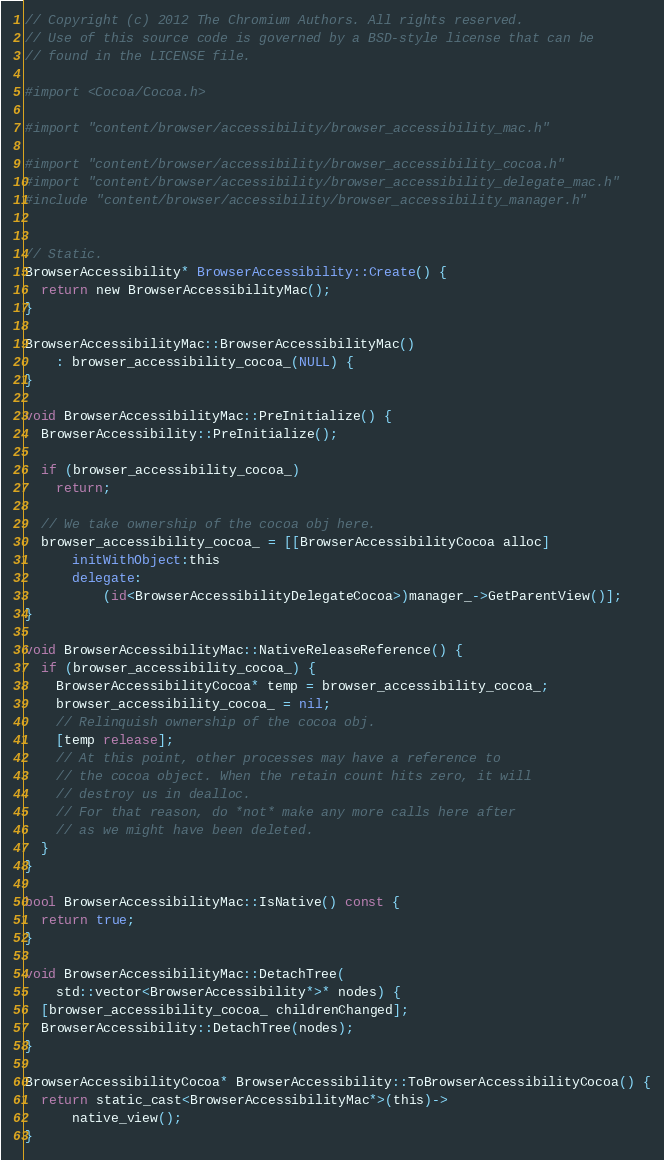<code> <loc_0><loc_0><loc_500><loc_500><_ObjectiveC_>// Copyright (c) 2012 The Chromium Authors. All rights reserved.
// Use of this source code is governed by a BSD-style license that can be
// found in the LICENSE file.

#import <Cocoa/Cocoa.h>

#import "content/browser/accessibility/browser_accessibility_mac.h"

#import "content/browser/accessibility/browser_accessibility_cocoa.h"
#import "content/browser/accessibility/browser_accessibility_delegate_mac.h"
#include "content/browser/accessibility/browser_accessibility_manager.h"


// Static.
BrowserAccessibility* BrowserAccessibility::Create() {
  return new BrowserAccessibilityMac();
}

BrowserAccessibilityMac::BrowserAccessibilityMac()
    : browser_accessibility_cocoa_(NULL) {
}

void BrowserAccessibilityMac::PreInitialize() {
  BrowserAccessibility::PreInitialize();

  if (browser_accessibility_cocoa_)
    return;

  // We take ownership of the cocoa obj here.
  browser_accessibility_cocoa_ = [[BrowserAccessibilityCocoa alloc]
      initWithObject:this
      delegate:
          (id<BrowserAccessibilityDelegateCocoa>)manager_->GetParentView()];
}

void BrowserAccessibilityMac::NativeReleaseReference() {
  if (browser_accessibility_cocoa_) {
    BrowserAccessibilityCocoa* temp = browser_accessibility_cocoa_;
    browser_accessibility_cocoa_ = nil;
    // Relinquish ownership of the cocoa obj.
    [temp release];
    // At this point, other processes may have a reference to
    // the cocoa object. When the retain count hits zero, it will
    // destroy us in dealloc.
    // For that reason, do *not* make any more calls here after
    // as we might have been deleted.
  }
}

bool BrowserAccessibilityMac::IsNative() const {
  return true;
}

void BrowserAccessibilityMac::DetachTree(
    std::vector<BrowserAccessibility*>* nodes) {
  [browser_accessibility_cocoa_ childrenChanged];
  BrowserAccessibility::DetachTree(nodes);
}

BrowserAccessibilityCocoa* BrowserAccessibility::ToBrowserAccessibilityCocoa() {
  return static_cast<BrowserAccessibilityMac*>(this)->
      native_view();
}
</code> 